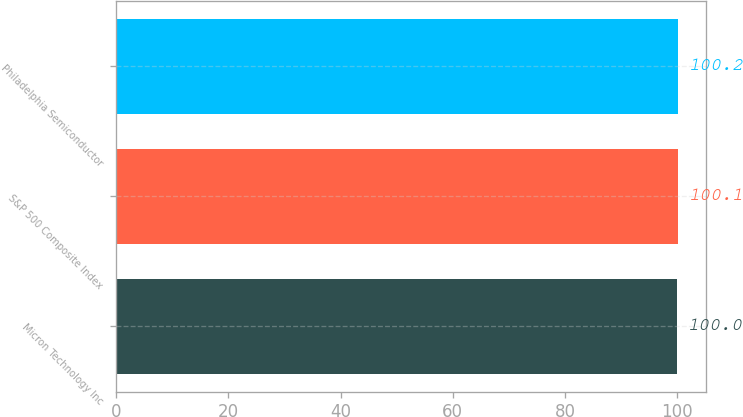Convert chart. <chart><loc_0><loc_0><loc_500><loc_500><bar_chart><fcel>Micron Technology Inc<fcel>S&P 500 Composite Index<fcel>Philadelphia Semiconductor<nl><fcel>100<fcel>100.1<fcel>100.2<nl></chart> 